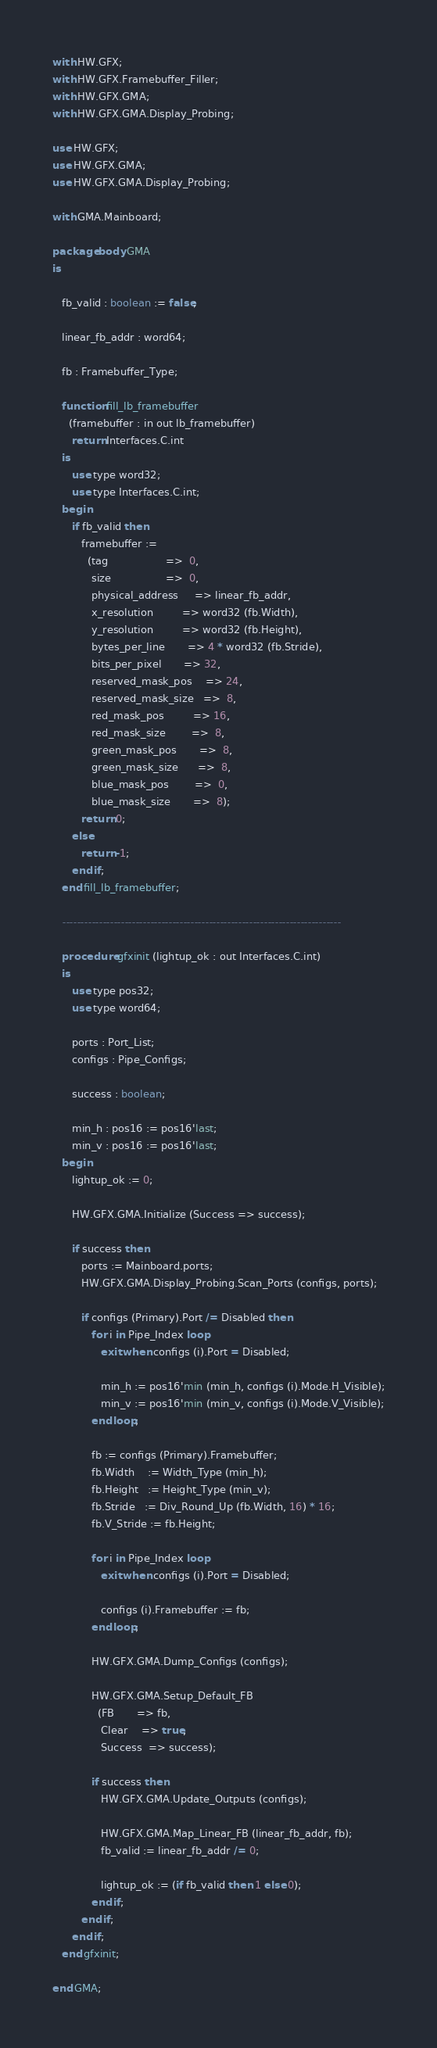Convert code to text. <code><loc_0><loc_0><loc_500><loc_500><_Ada_>with HW.GFX;
with HW.GFX.Framebuffer_Filler;
with HW.GFX.GMA;
with HW.GFX.GMA.Display_Probing;

use HW.GFX;
use HW.GFX.GMA;
use HW.GFX.GMA.Display_Probing;

with GMA.Mainboard;

package body GMA
is

   fb_valid : boolean := false;

   linear_fb_addr : word64;

   fb : Framebuffer_Type;

   function fill_lb_framebuffer
     (framebuffer : in out lb_framebuffer)
      return Interfaces.C.int
   is
      use type word32;
      use type Interfaces.C.int;
   begin
      if fb_valid then
         framebuffer :=
           (tag                  =>  0,
            size                 =>  0,
            physical_address     => linear_fb_addr,
            x_resolution         => word32 (fb.Width),
            y_resolution         => word32 (fb.Height),
            bytes_per_line       => 4 * word32 (fb.Stride),
            bits_per_pixel       => 32,
            reserved_mask_pos    => 24,
            reserved_mask_size   =>  8,
            red_mask_pos         => 16,
            red_mask_size        =>  8,
            green_mask_pos       =>  8,
            green_mask_size      =>  8,
            blue_mask_pos        =>  0,
            blue_mask_size       =>  8);
         return 0;
      else
         return -1;
      end if;
   end fill_lb_framebuffer;

   ----------------------------------------------------------------------------

   procedure gfxinit (lightup_ok : out Interfaces.C.int)
   is
      use type pos32;
      use type word64;

      ports : Port_List;
      configs : Pipe_Configs;

      success : boolean;

      min_h : pos16 := pos16'last;
      min_v : pos16 := pos16'last;
   begin
      lightup_ok := 0;

      HW.GFX.GMA.Initialize (Success => success);

      if success then
         ports := Mainboard.ports;
         HW.GFX.GMA.Display_Probing.Scan_Ports (configs, ports);

         if configs (Primary).Port /= Disabled then
            for i in Pipe_Index loop
               exit when configs (i).Port = Disabled;

               min_h := pos16'min (min_h, configs (i).Mode.H_Visible);
               min_v := pos16'min (min_v, configs (i).Mode.V_Visible);
            end loop;

            fb := configs (Primary).Framebuffer;
            fb.Width    := Width_Type (min_h);
            fb.Height   := Height_Type (min_v);
            fb.Stride   := Div_Round_Up (fb.Width, 16) * 16;
            fb.V_Stride := fb.Height;

            for i in Pipe_Index loop
               exit when configs (i).Port = Disabled;

               configs (i).Framebuffer := fb;
            end loop;

            HW.GFX.GMA.Dump_Configs (configs);

            HW.GFX.GMA.Setup_Default_FB
              (FB       => fb,
               Clear    => true,
               Success  => success);

            if success then
               HW.GFX.GMA.Update_Outputs (configs);

               HW.GFX.GMA.Map_Linear_FB (linear_fb_addr, fb);
               fb_valid := linear_fb_addr /= 0;

               lightup_ok := (if fb_valid then 1 else 0);
            end if;
         end if;
      end if;
   end gfxinit;

end GMA;
</code> 